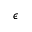Convert formula to latex. <formula><loc_0><loc_0><loc_500><loc_500>\epsilon</formula> 